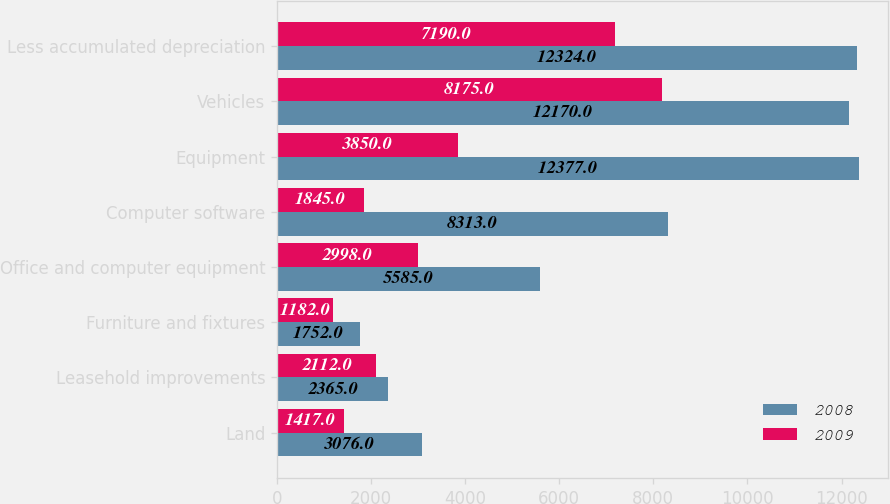Convert chart to OTSL. <chart><loc_0><loc_0><loc_500><loc_500><stacked_bar_chart><ecel><fcel>Land<fcel>Leasehold improvements<fcel>Furniture and fixtures<fcel>Office and computer equipment<fcel>Computer software<fcel>Equipment<fcel>Vehicles<fcel>Less accumulated depreciation<nl><fcel>2008<fcel>3076<fcel>2365<fcel>1752<fcel>5585<fcel>8313<fcel>12377<fcel>12170<fcel>12324<nl><fcel>2009<fcel>1417<fcel>2112<fcel>1182<fcel>2998<fcel>1845<fcel>3850<fcel>8175<fcel>7190<nl></chart> 